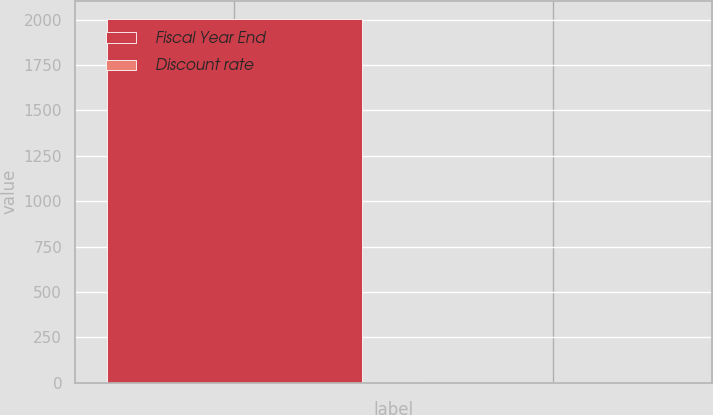Convert chart to OTSL. <chart><loc_0><loc_0><loc_500><loc_500><bar_chart><fcel>Fiscal Year End<fcel>Discount rate<nl><fcel>2005<fcel>5.55<nl></chart> 